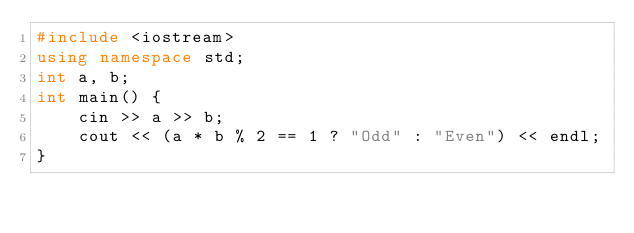Convert code to text. <code><loc_0><loc_0><loc_500><loc_500><_C++_>#include <iostream>
using namespace std;
int a, b;
int main() {
	cin >> a >> b;
	cout << (a * b % 2 == 1 ? "Odd" : "Even") << endl;
}
</code> 